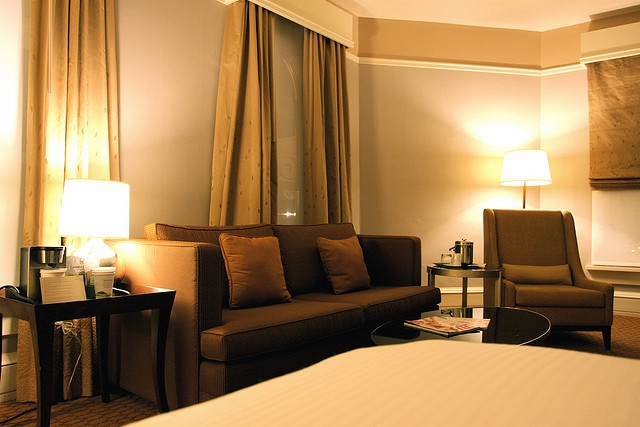Describe the objects in this image and their specific colors. I can see couch in tan, black, maroon, brown, and orange tones, bed in tan and black tones, chair in tan, maroon, black, and brown tones, book in tan, black, brown, and olive tones, and cup in tan, olive, and beige tones in this image. 